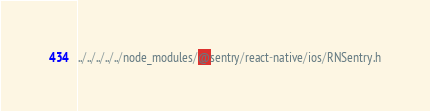<code> <loc_0><loc_0><loc_500><loc_500><_C_>../../../../../node_modules/@sentry/react-native/ios/RNSentry.h</code> 